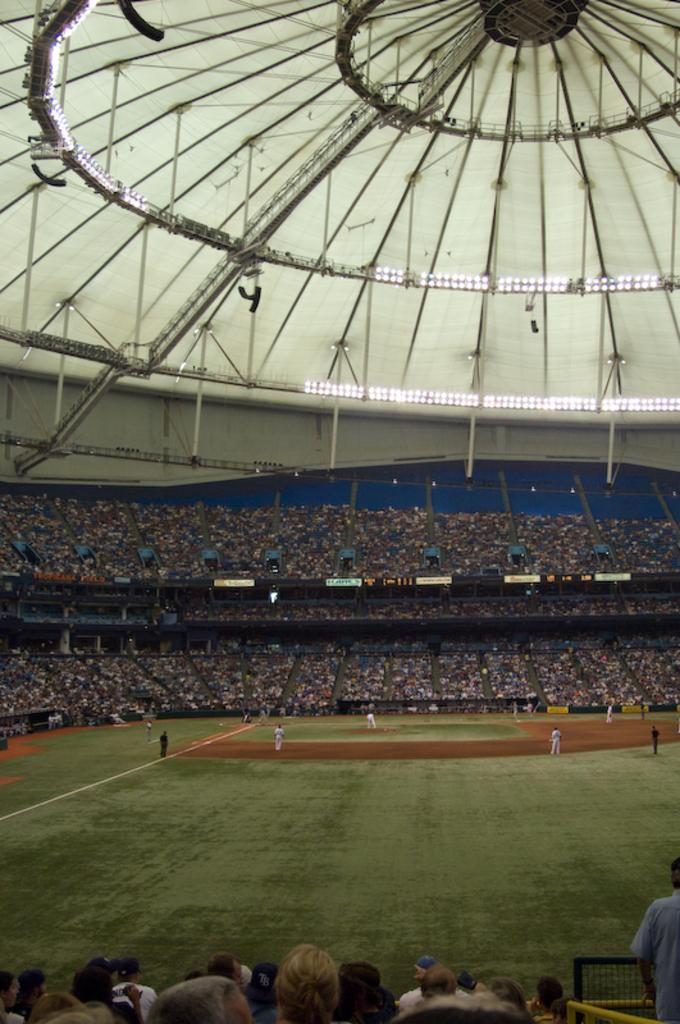How would you summarize this image in a sentence or two? In this picture I can see a stadium. I can also see group of people among the some are standing on the ground. Here I can see grass and white line on the ground. 